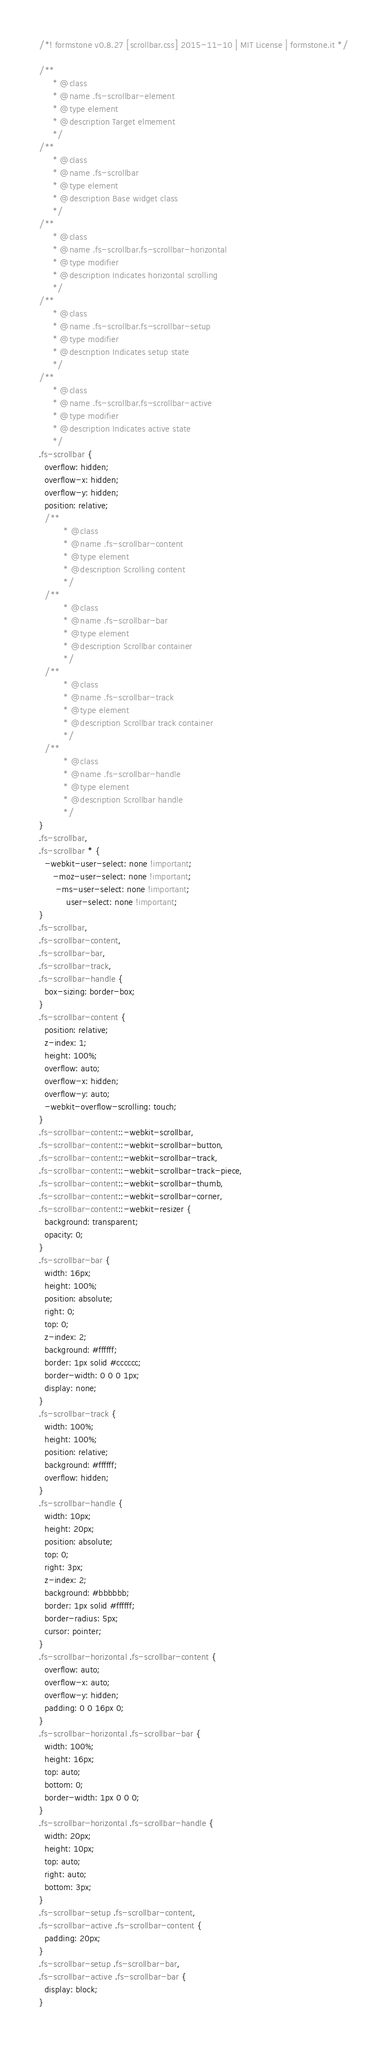<code> <loc_0><loc_0><loc_500><loc_500><_CSS_>/*! formstone v0.8.27 [scrollbar.css] 2015-11-10 | MIT License | formstone.it */

/**
	 * @class
	 * @name .fs-scrollbar-element
	 * @type element
	 * @description Target elmement
	 */
/**
	 * @class
	 * @name .fs-scrollbar
	 * @type element
	 * @description Base widget class
	 */
/**
	 * @class
	 * @name .fs-scrollbar.fs-scrollbar-horizontal
	 * @type modifier
	 * @description Indicates horizontal scrolling
	 */
/**
	 * @class
	 * @name .fs-scrollbar.fs-scrollbar-setup
	 * @type modifier
	 * @description Indicates setup state
	 */
/**
	 * @class
	 * @name .fs-scrollbar.fs-scrollbar-active
	 * @type modifier
	 * @description Indicates active state
	 */
.fs-scrollbar {
  overflow: hidden;
  overflow-x: hidden;
  overflow-y: hidden;
  position: relative;
  /**
		 * @class
		 * @name .fs-scrollbar-content
		 * @type element
		 * @description Scrolling content
		 */
  /**
		 * @class
		 * @name .fs-scrollbar-bar
		 * @type element
		 * @description Scrollbar container
		 */
  /**
		 * @class
		 * @name .fs-scrollbar-track
		 * @type element
		 * @description Scrollbar track container
		 */
  /**
		 * @class
		 * @name .fs-scrollbar-handle
		 * @type element
		 * @description Scrollbar handle
		 */
}
.fs-scrollbar,
.fs-scrollbar * {
  -webkit-user-select: none !important;
     -moz-user-select: none !important;
      -ms-user-select: none !important;
          user-select: none !important;
}
.fs-scrollbar,
.fs-scrollbar-content,
.fs-scrollbar-bar,
.fs-scrollbar-track,
.fs-scrollbar-handle {
  box-sizing: border-box;
}
.fs-scrollbar-content {
  position: relative;
  z-index: 1;
  height: 100%;
  overflow: auto;
  overflow-x: hidden;
  overflow-y: auto;
  -webkit-overflow-scrolling: touch;
}
.fs-scrollbar-content::-webkit-scrollbar,
.fs-scrollbar-content::-webkit-scrollbar-button,
.fs-scrollbar-content::-webkit-scrollbar-track,
.fs-scrollbar-content::-webkit-scrollbar-track-piece,
.fs-scrollbar-content::-webkit-scrollbar-thumb,
.fs-scrollbar-content::-webkit-scrollbar-corner,
.fs-scrollbar-content::-webkit-resizer {
  background: transparent;
  opacity: 0;
}
.fs-scrollbar-bar {
  width: 16px;
  height: 100%;
  position: absolute;
  right: 0;
  top: 0;
  z-index: 2;
  background: #ffffff;
  border: 1px solid #cccccc;
  border-width: 0 0 0 1px;
  display: none;
}
.fs-scrollbar-track {
  width: 100%;
  height: 100%;
  position: relative;
  background: #ffffff;
  overflow: hidden;
}
.fs-scrollbar-handle {
  width: 10px;
  height: 20px;
  position: absolute;
  top: 0;
  right: 3px;
  z-index: 2;
  background: #bbbbbb;
  border: 1px solid #ffffff;
  border-radius: 5px;
  cursor: pointer;
}
.fs-scrollbar-horizontal .fs-scrollbar-content {
  overflow: auto;
  overflow-x: auto;
  overflow-y: hidden;
  padding: 0 0 16px 0;
}
.fs-scrollbar-horizontal .fs-scrollbar-bar {
  width: 100%;
  height: 16px;
  top: auto;
  bottom: 0;
  border-width: 1px 0 0 0;
}
.fs-scrollbar-horizontal .fs-scrollbar-handle {
  width: 20px;
  height: 10px;
  top: auto;
  right: auto;
  bottom: 3px;
}
.fs-scrollbar-setup .fs-scrollbar-content,
.fs-scrollbar-active .fs-scrollbar-content {
  padding: 20px;
}
.fs-scrollbar-setup .fs-scrollbar-bar,
.fs-scrollbar-active .fs-scrollbar-bar {
  display: block;
}
</code> 